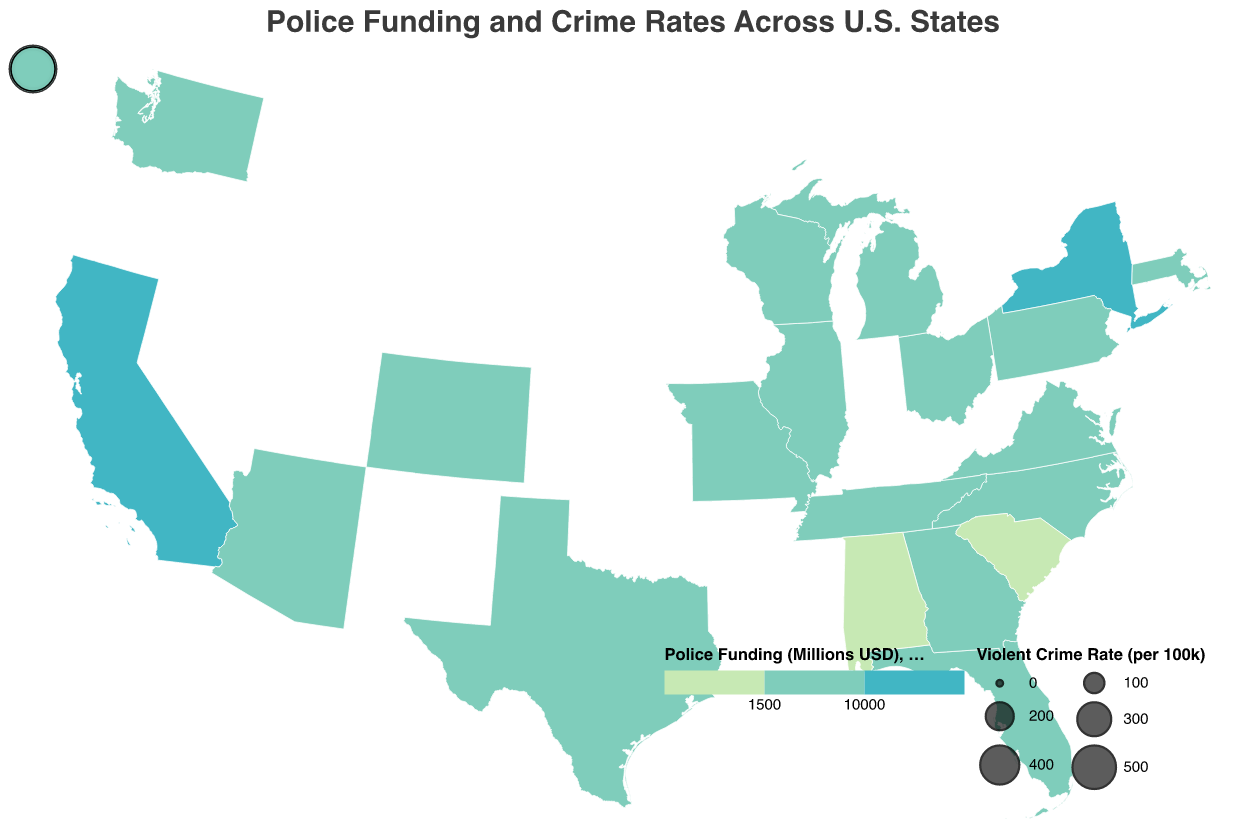What is the title of the figure? The title of the figure is displayed at the top and is "Police Funding and Crime Rates Across U.S. States".
Answer: Police Funding and Crime Rates Across U.S. States Which state has the highest police funding? By looking at the shades representing police funding levels, California has the darkest shade, indicating the highest funding.
Answer: California Which state has the lowest violent crime rate? By comparing the sizes of the circles representing violent crime rates, Virginia has the smallest circle, indicating the lowest violent crime rate.
Answer: Virginia What is the violent crime rate in Florida? Hovering over or referencing Florida shows a tooltip that includes the violent crime rate, which is 384 per 100k.
Answer: 384 per 100k Calculate the average police funding across all states. Sum the police funding of all states and divide by the number of states. (15200 + 8900 + 7600 + 10500 + 4800 + 3200 + 2900 + 3100 + 2700 + 2400 + 2200 + 2000 + 2300 + 1800 + 1600 + 1900 + 1500 + 1700 + 1200 + 1100) / 20 = 3,995 million USD.
Answer: 3,995 million USD Which states have both violent and property crime rates higher than 300 and 2500 per 100k, respectively? Referring to the tooltip information, South Carolina fits the criteria with 511 violent and 2902 property crime rates, and Tennessee with 595 violent and 2805 property crime rates.
Answer: South Carolina, Tennessee Compare the property crime rate of Texas and Ohio. Which one is higher? By comparing the tooltip values, Texas has a property crime rate of 2390 while Ohio has 2053, thus Texas has a higher property crime rate.
Answer: Texas What color represents police funding between 5000 and 10000 million USD? The legend indicates that the color for this range is "#41b6c4" or a bluish-green color.
Answer: Bluish-green Which state has the largest circle (highest violent crime rate)? Tennessee has the largest circle representing the highest violent crime rate of 595 per 100k.
Answer: Tennessee 